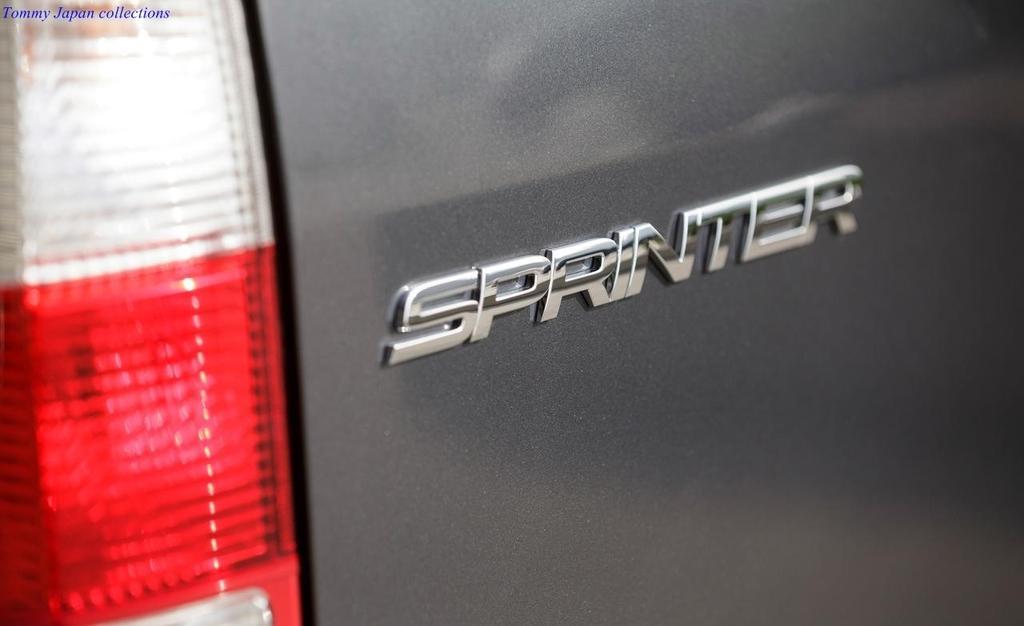Can you describe this image briefly? In the picture we can see a backside part of the car which is gray in color and name on it as a sprinter and beside it we can see a stoplight. 